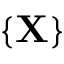<formula> <loc_0><loc_0><loc_500><loc_500>\{ { \mathbf X } \}</formula> 